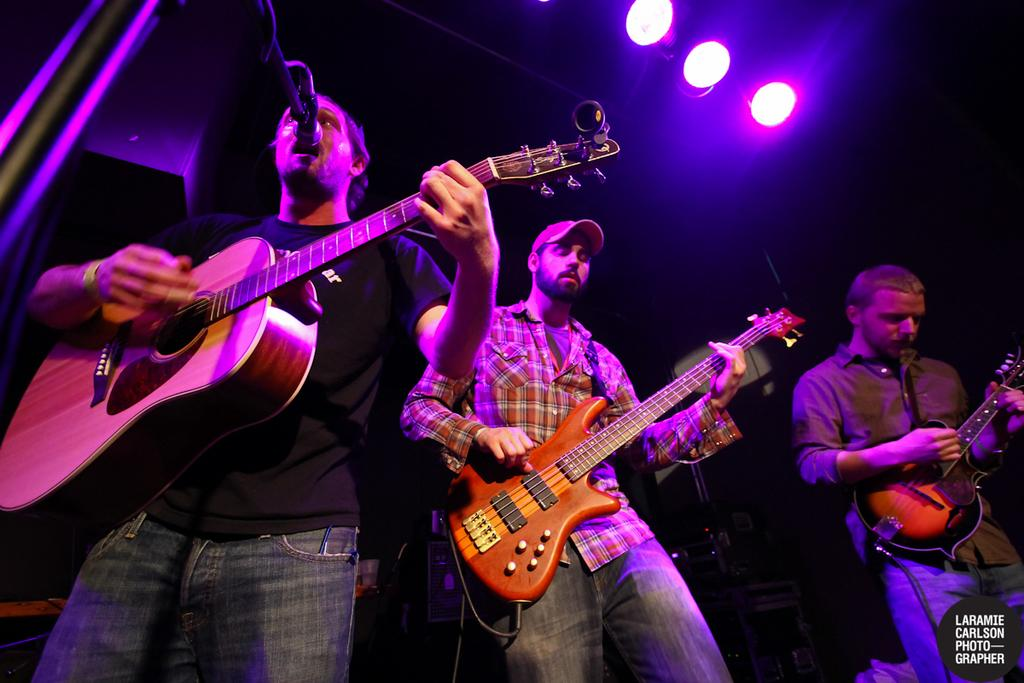How many people are in the image? There are three men in the image. What are the men holding in the image? Each man is holding a guitar. What is one of the men doing with a microphone? One man is singing into a microphone. Can you describe the background of the image? There is a dark and light background in the image. Where is the frog sitting in the image? There is no frog present in the image. What is the birth date of the man playing the guitar in the image? The provided facts do not include information about the birth date of any of the men in the image. 